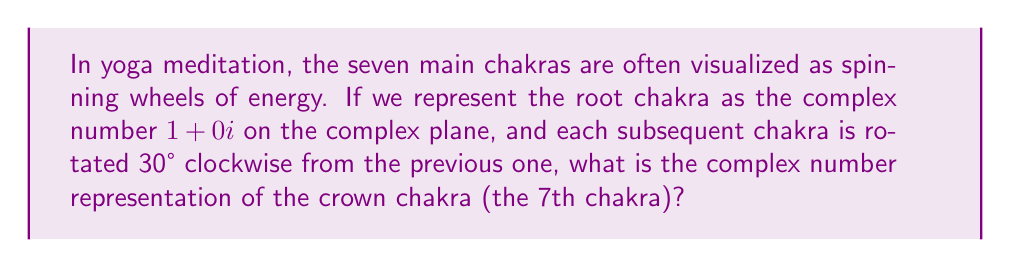Give your solution to this math problem. Let's approach this step-by-step:

1) We start with the root chakra at $1+0i$.

2) Each rotation of 30° clockwise can be represented by multiplying the complex number by $\cos(-30°) + i\sin(-30°)$, or equivalently, $\cos(30°) - i\sin(30°)$.

3) We can use De Moivre's formula: $(\cos\theta + i\sin\theta)^n = \cos(n\theta) + i\sin(n\theta)$

4) In our case, $\theta = 30°$ and $n = 6$ (as we're rotating 6 times to get from the 1st to the 7th chakra).

5) So, we need to calculate:
   $$(1+0i) \cdot (\cos(30°) - i\sin(30°))^6$$

6) Using De Moivre's formula:
   $$(1+0i) \cdot (\cos(180°) - i\sin(180°))$$

7) We know that $\cos(180°) = -1$ and $\sin(180°) = 0$, so:
   $$(1+0i) \cdot (-1 - 0i) = -1 + 0i$$

Therefore, the crown chakra is represented by the complex number $-1+0i$.
Answer: $-1+0i$ 